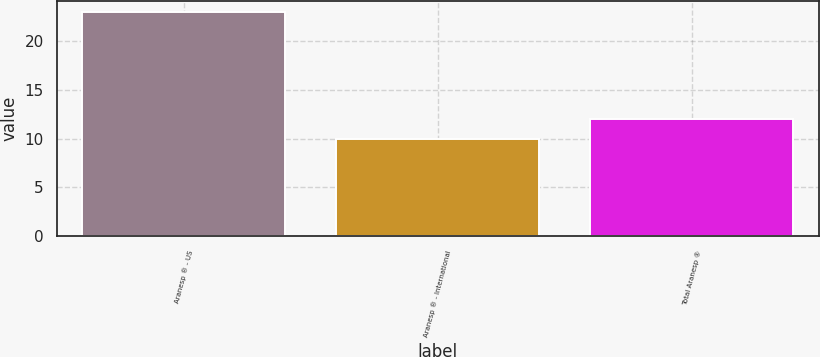Convert chart. <chart><loc_0><loc_0><loc_500><loc_500><bar_chart><fcel>Aranesp ® - US<fcel>Aranesp ® - International<fcel>Total Aranesp ®<nl><fcel>23<fcel>10<fcel>12<nl></chart> 